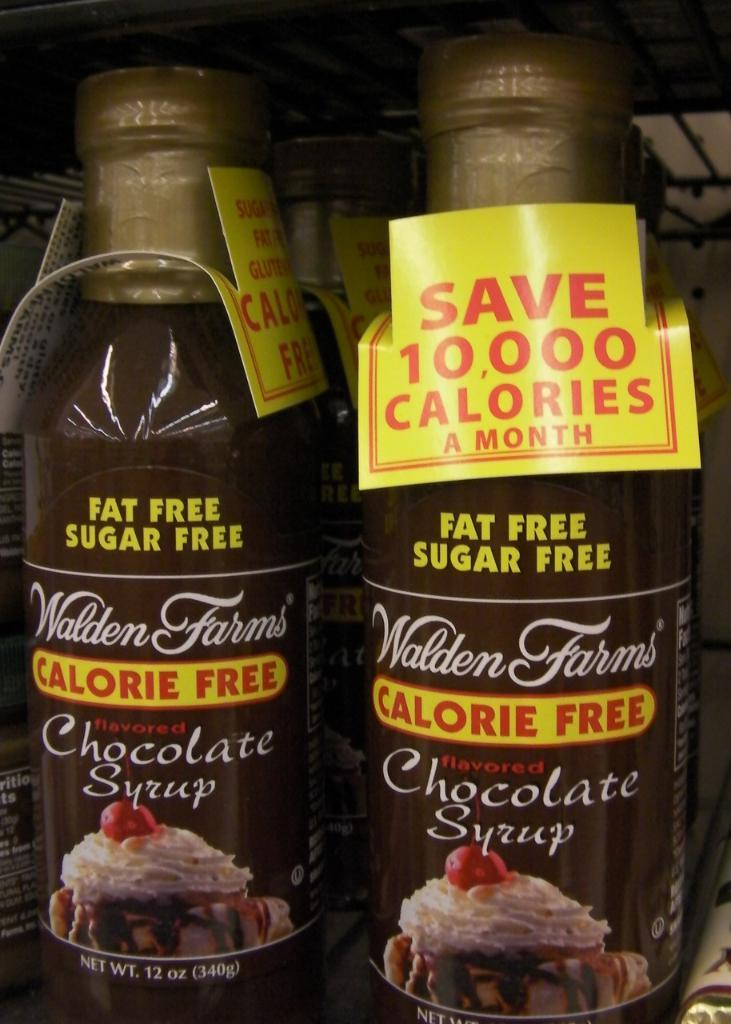What objects in the image have tags and stickers on them? There are bottles with tags and stickers in the image. What can be seen at the top of the image? There is a grill visible at the top of the image. What is in the background of the image? There is a wall in the background of the image. What type of war is being depicted in the image? There is no depiction of war in the image; it features bottles with tags and stickers, a grill, and a wall in the background. 